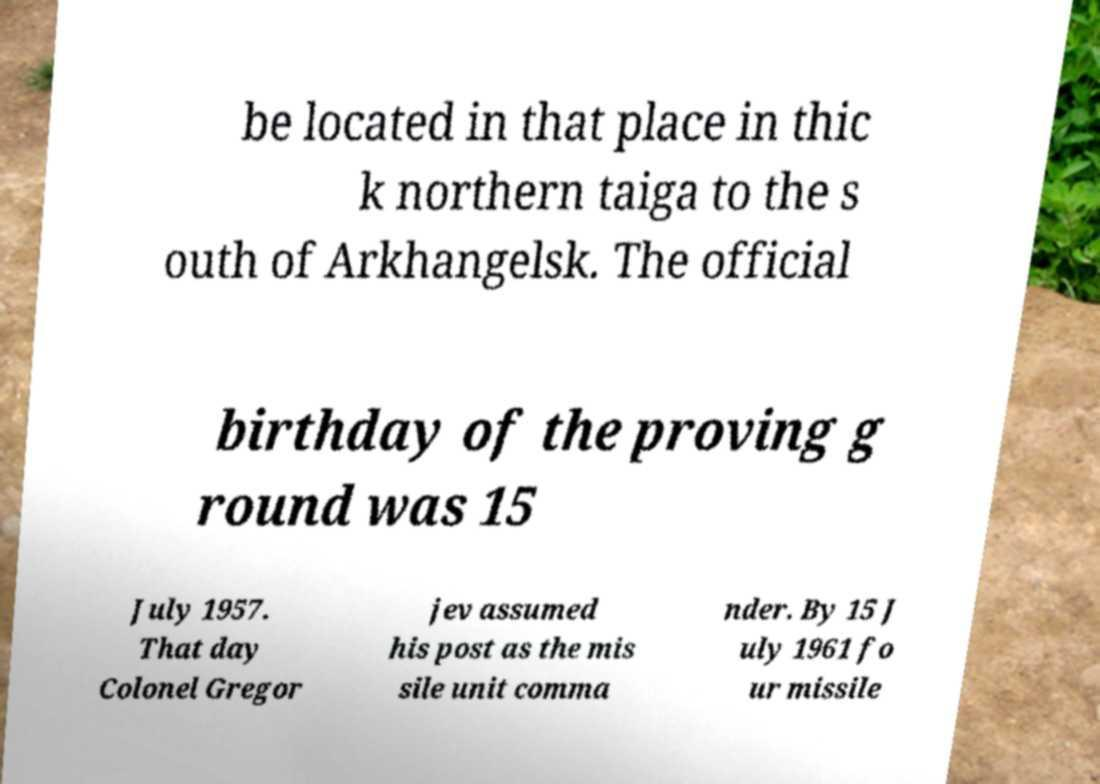Please identify and transcribe the text found in this image. be located in that place in thic k northern taiga to the s outh of Arkhangelsk. The official birthday of the proving g round was 15 July 1957. That day Colonel Gregor jev assumed his post as the mis sile unit comma nder. By 15 J uly 1961 fo ur missile 